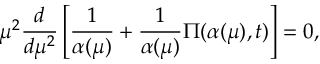<formula> <loc_0><loc_0><loc_500><loc_500>\mu ^ { 2 } \frac { d } { d \mu ^ { 2 } } \left [ \frac { 1 } { \alpha ( \mu ) } + \frac { 1 } { \alpha ( \mu ) } \Pi ( \alpha ( \mu ) , t ) \right ] = 0 ,</formula> 